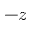Convert formula to latex. <formula><loc_0><loc_0><loc_500><loc_500>- z</formula> 